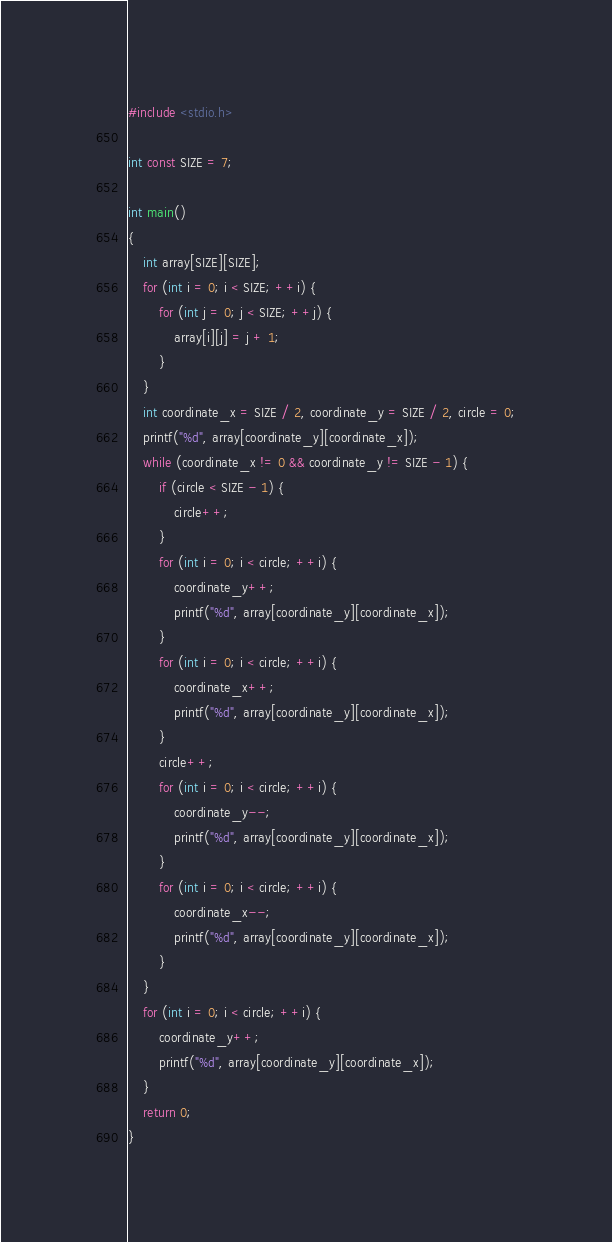<code> <loc_0><loc_0><loc_500><loc_500><_C_>#include <stdio.h>

int const SIZE = 7;

int main()
{
    int array[SIZE][SIZE];
    for (int i = 0; i < SIZE; ++i) {
        for (int j = 0; j < SIZE; ++j) {
            array[i][j] = j + 1;
        }
    }
    int coordinate_x = SIZE / 2, coordinate_y = SIZE / 2, circle = 0;
    printf("%d", array[coordinate_y][coordinate_x]);
    while (coordinate_x != 0 && coordinate_y != SIZE - 1) {
        if (circle < SIZE - 1) {
            circle++;
        }
        for (int i = 0; i < circle; ++i) {
            coordinate_y++;
            printf("%d", array[coordinate_y][coordinate_x]);
        }
        for (int i = 0; i < circle; ++i) {
            coordinate_x++;
            printf("%d", array[coordinate_y][coordinate_x]);
        }
        circle++;
        for (int i = 0; i < circle; ++i) {
            coordinate_y--;
            printf("%d", array[coordinate_y][coordinate_x]);
        }
        for (int i = 0; i < circle; ++i) {
            coordinate_x--;
            printf("%d", array[coordinate_y][coordinate_x]);
        }
    }
    for (int i = 0; i < circle; ++i) {
        coordinate_y++;
        printf("%d", array[coordinate_y][coordinate_x]);
    }
    return 0;
}
</code> 